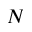Convert formula to latex. <formula><loc_0><loc_0><loc_500><loc_500>N</formula> 